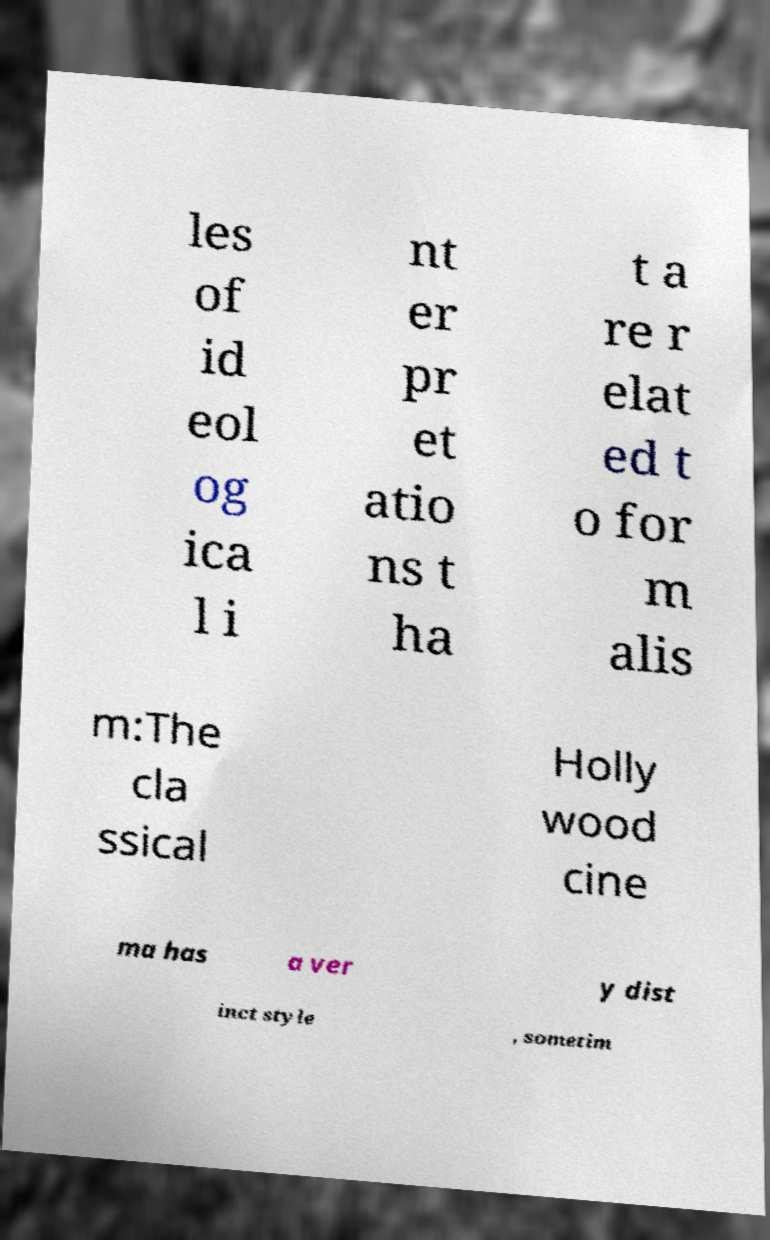Can you read and provide the text displayed in the image?This photo seems to have some interesting text. Can you extract and type it out for me? les of id eol og ica l i nt er pr et atio ns t ha t a re r elat ed t o for m alis m:The cla ssical Holly wood cine ma has a ver y dist inct style , sometim 